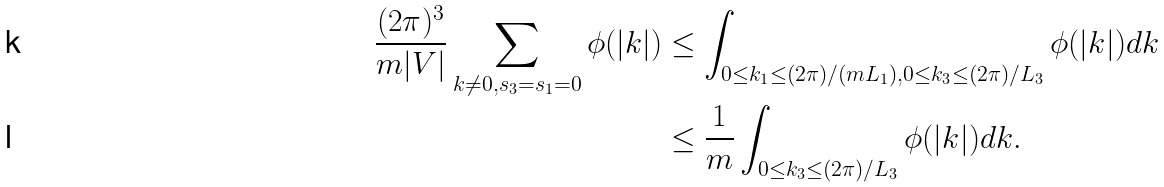<formula> <loc_0><loc_0><loc_500><loc_500>\frac { ( 2 \pi ) ^ { 3 } } { m | V | } \sum _ { k \not = 0 , s _ { 3 } = s _ { 1 } = 0 } \phi ( | k | ) & \leq \int _ { 0 \leq k _ { 1 } \leq ( 2 \pi ) / ( m L _ { 1 } ) , 0 \leq k _ { 3 } \leq ( 2 \pi ) / L _ { 3 } } \phi ( | k | ) d k \\ & \leq \frac { 1 } { m } \int _ { 0 \leq k _ { 3 } \leq ( 2 \pi ) / L _ { 3 } } \phi ( | k | ) d k .</formula> 